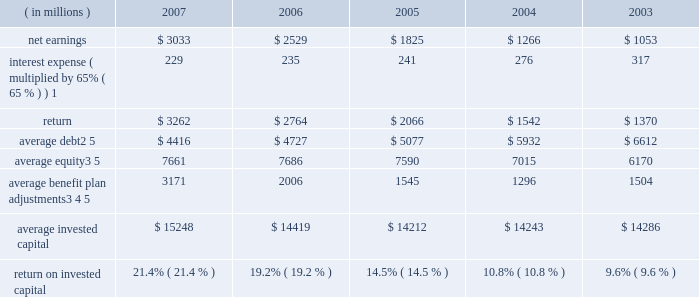( c ) includes the effects of items not considered in the assessment of the operating performance of our business segments which increased operating profit by $ 230 million , $ 150 million after tax ( $ 0.34 per share ) .
Also includes expenses of $ 16 million , $ 11 million after tax ( $ 0.03 per share ) for a debt exchange , and a reduction in income tax expense of $ 62 million ( $ 0.14 per share ) resulting from a tax benefit related to claims we filed for additional extraterritorial income exclusion ( eti ) tax benefits .
On a combined basis , these items increased earnings by $ 201 million after tax ( $ 0.45 per share ) .
( d ) includes the effects of items not considered in the assessment of the operating performance of our business segments which , on a combined basis , increased operating profit by $ 173 million , $ 113 million after tax ( $ 0.25 per share ) .
( e ) includes the effects of items not considered in the assessment of the operating performance of our business segments which decreased operating profit by $ 61 million , $ 54 million after tax ( $ 0.12 per share ) .
Also includes a charge of $ 154 million , $ 100 million after tax ( $ 0.22 per share ) for the early repayment of debt , and a reduction in income tax expense resulting from the closure of an internal revenue service examination of $ 144 million ( $ 0.32 per share ) .
On a combined basis , these items reduced earnings by $ 10 million after tax ( $ 0.02 per share ) .
( f ) includes the effects of items not considered in the assessment of the operating performance of our business segments which , on a combined basis , decreased operating profit by $ 7 million , $ 6 million after tax ( $ 0.01 per share ) .
Also includes a charge of $ 146 million , $ 96 million after tax ( $ 0.21 per share ) for the early repayment of debt .
( g ) we define return on invested capital ( roic ) as net earnings plus after-tax interest expense divided by average invested capital ( stockholders 2019 equity plus debt ) , after adjusting stockholders 2019 equity by adding back adjustments related to postretirement benefit plans .
We believe that reporting roic provides investors with greater visibility into how effectively we use the capital invested in our operations .
We use roic to evaluate multi-year investment decisions and as a long-term performance measure , and also use it as a factor in evaluating management performance under certain of our incentive compensation plans .
Roic is not a measure of financial performance under generally accepted accounting principles , and may not be defined and calculated by other companies in the same manner .
Roic should not be considered in isolation or as an alternative to net earnings as an indicator of performance .
We calculate roic as follows : ( in millions ) 2007 2006 2005 2004 2003 .
1 represents after-tax interest expense utilizing the federal statutory rate of 35% ( 35 % ) .
2 debt consists of long-term debt , including current maturities of long-term debt , and short-term borrowings ( if any ) .
3 equity includes non-cash adjustments , primarily for unrecognized benefit plan actuarial losses and prior service costs in 2007 and 2006 , the adjustment for the adoption of fas 158 in 2006 , and the additional minimum pension liability in years prior to 2007 .
4 average benefit plan adjustments reflect the cumulative value of entries identified in our statement of stockholders equity under the captions 201cpostretirement benefit plans , 201d 201cadjustment for adoption of fas 158 201d and 201cminimum pension liability . 201d the total of annual benefit plan adjustments to equity were : 2007 = $ 1706 million ; 2006 = ( $ 1883 ) million ; 2005 = ( $ 105 ) million ; 2004 = ( $ 285 ) million ; 2003 = $ 331 million ; 2002 = ( $ 1537 million ) ; and 2001 = ( $ 33 million ) .
As these entries are recorded in the fourth quarter , the value added back to our average equity in a given year is the cumulative impact of all prior year entries plus 20% ( 20 % ) of the current year entry value .
5 yearly averages are calculated using balances at the start of the year and at the end of each quarter. .
What was the average return on invested capital from 2003 to 2007? 
Computations: table_average(return on invested capital, none)
Answer: 0.151. 